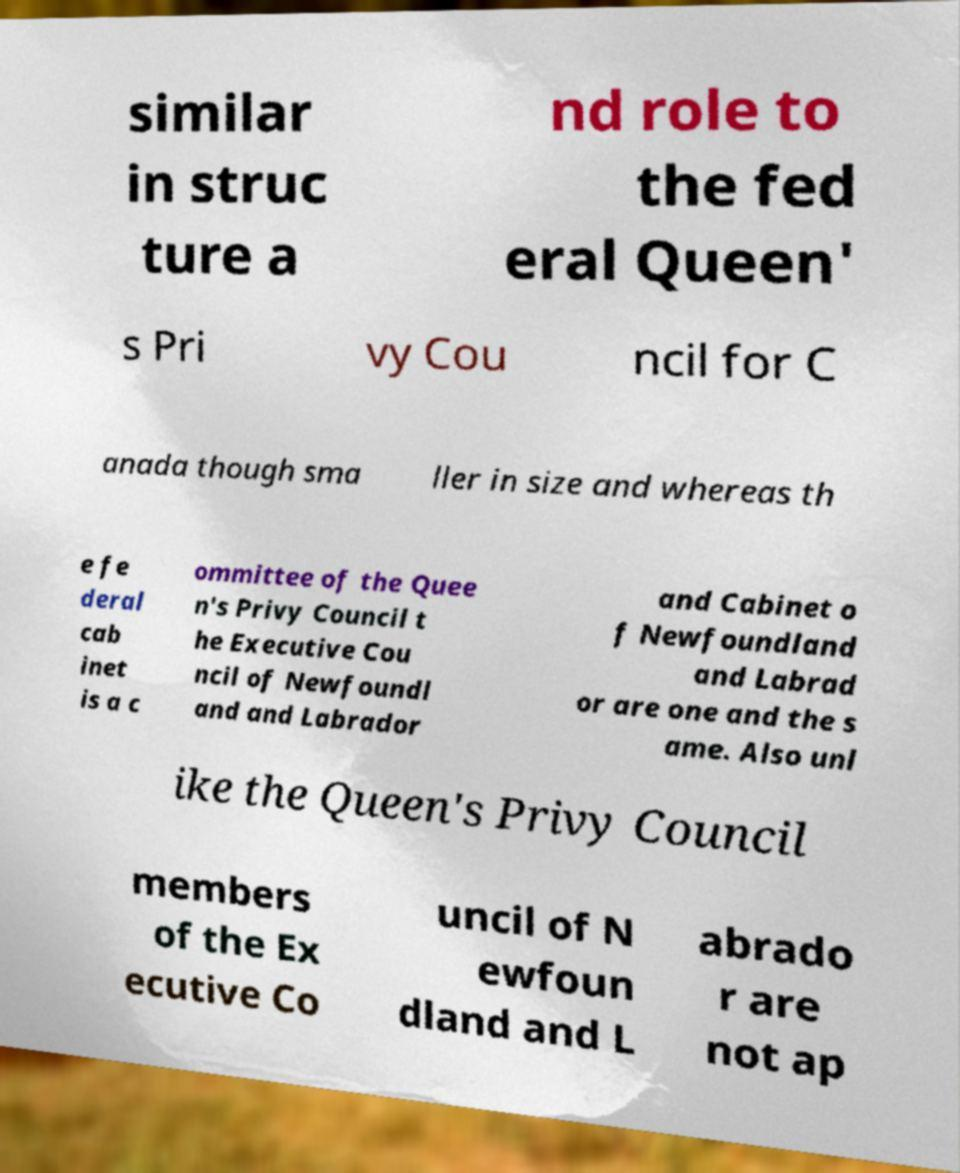For documentation purposes, I need the text within this image transcribed. Could you provide that? similar in struc ture a nd role to the fed eral Queen' s Pri vy Cou ncil for C anada though sma ller in size and whereas th e fe deral cab inet is a c ommittee of the Quee n's Privy Council t he Executive Cou ncil of Newfoundl and and Labrador and Cabinet o f Newfoundland and Labrad or are one and the s ame. Also unl ike the Queen's Privy Council members of the Ex ecutive Co uncil of N ewfoun dland and L abrado r are not ap 